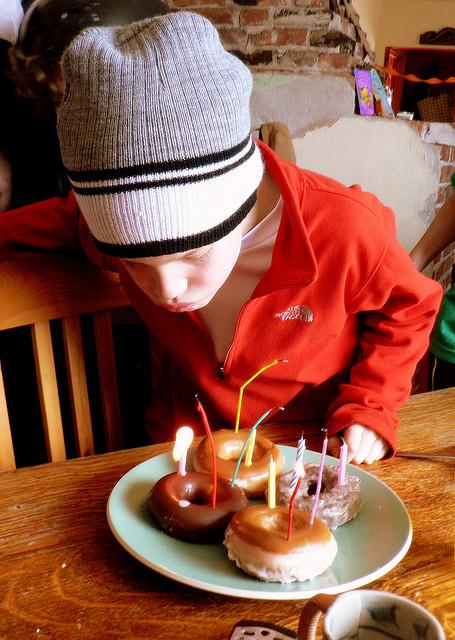What is the boy about to do? blow candles 